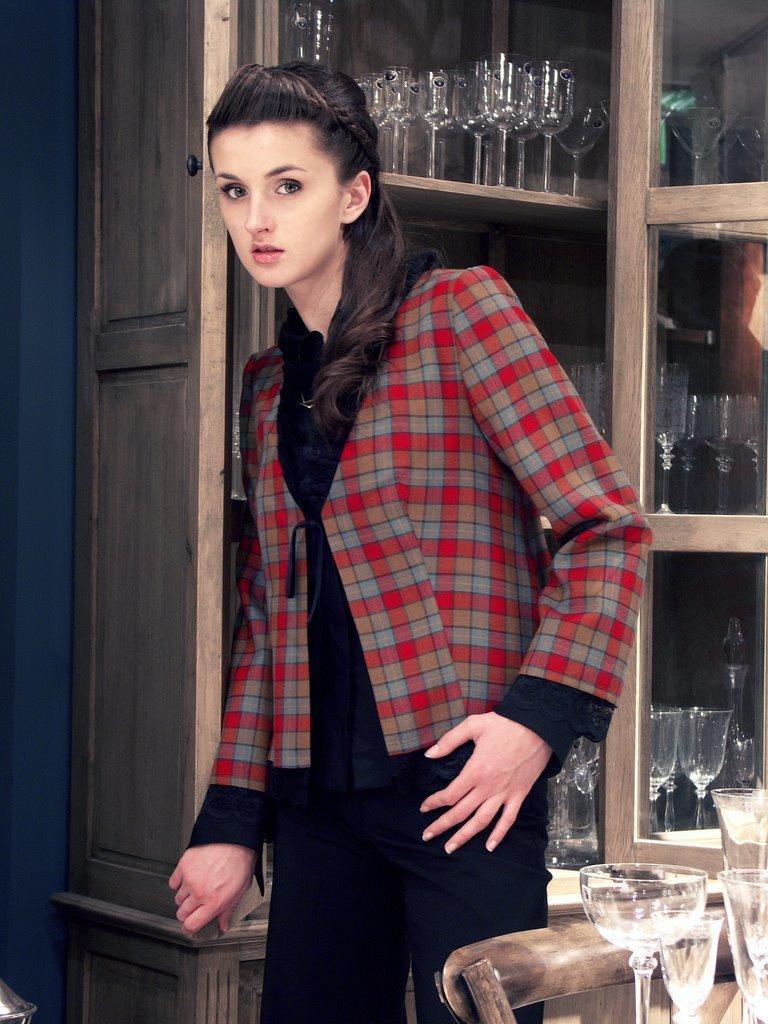Can you describe this image briefly? In this image, I can see the woman standing. Behind the woman, I can see the wine glasses, which are kept in a cupboard. At the bottom right side of the image, there are few more wine glasses and a chair. 